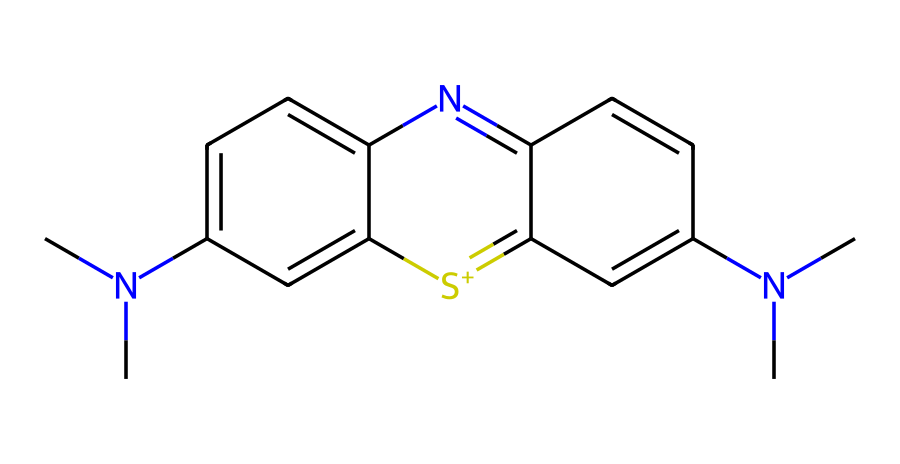What is the molecular formula of methylene blue? Analyzing the given SMILES representation, we find that it contains 16 carbons (C), 18 hydrogens (H), 2 nitrogens (N), and 1 sulfur (S). Thus, the molecular formula is C16H18N2S.
Answer: C16H18N2S How many nitrogen atoms are present in methylene blue? In the chemical structure as represented in the SMILES, there are two 'N' symbols, which indicate the presence of two nitrogen atoms.
Answer: 2 What type of chemical compound is methylene blue? Methylene blue is classified as a dye and is also used in medicine, particularly in treating methemoglobinemia and as a psychiatric medication, hence it is a synthetic dye.
Answer: synthetic dye Which functional groups are present in the structure of methylene blue? The structure contains two dimethylamine groups (-N(CH3)2) and a thiazine ring, which are essential for its dye and pharmaceutical properties. These functional groups are key to its function as a dye.
Answer: dimethylamine and thiazine What is the significance of the sulfur atom in methylene blue? The sulfur atom in the chemical structure is part of a thiazine ring, which is crucial for the dye's characteristics, including its color and light-absorbing properties.
Answer: light-absorbing What color does methylene blue impart when dissolved? Methylene blue, when dissolved in water, gives a blue color due to its absorbance of certain wavelengths of light associated with its electronic structure and conjugated system.
Answer: blue 